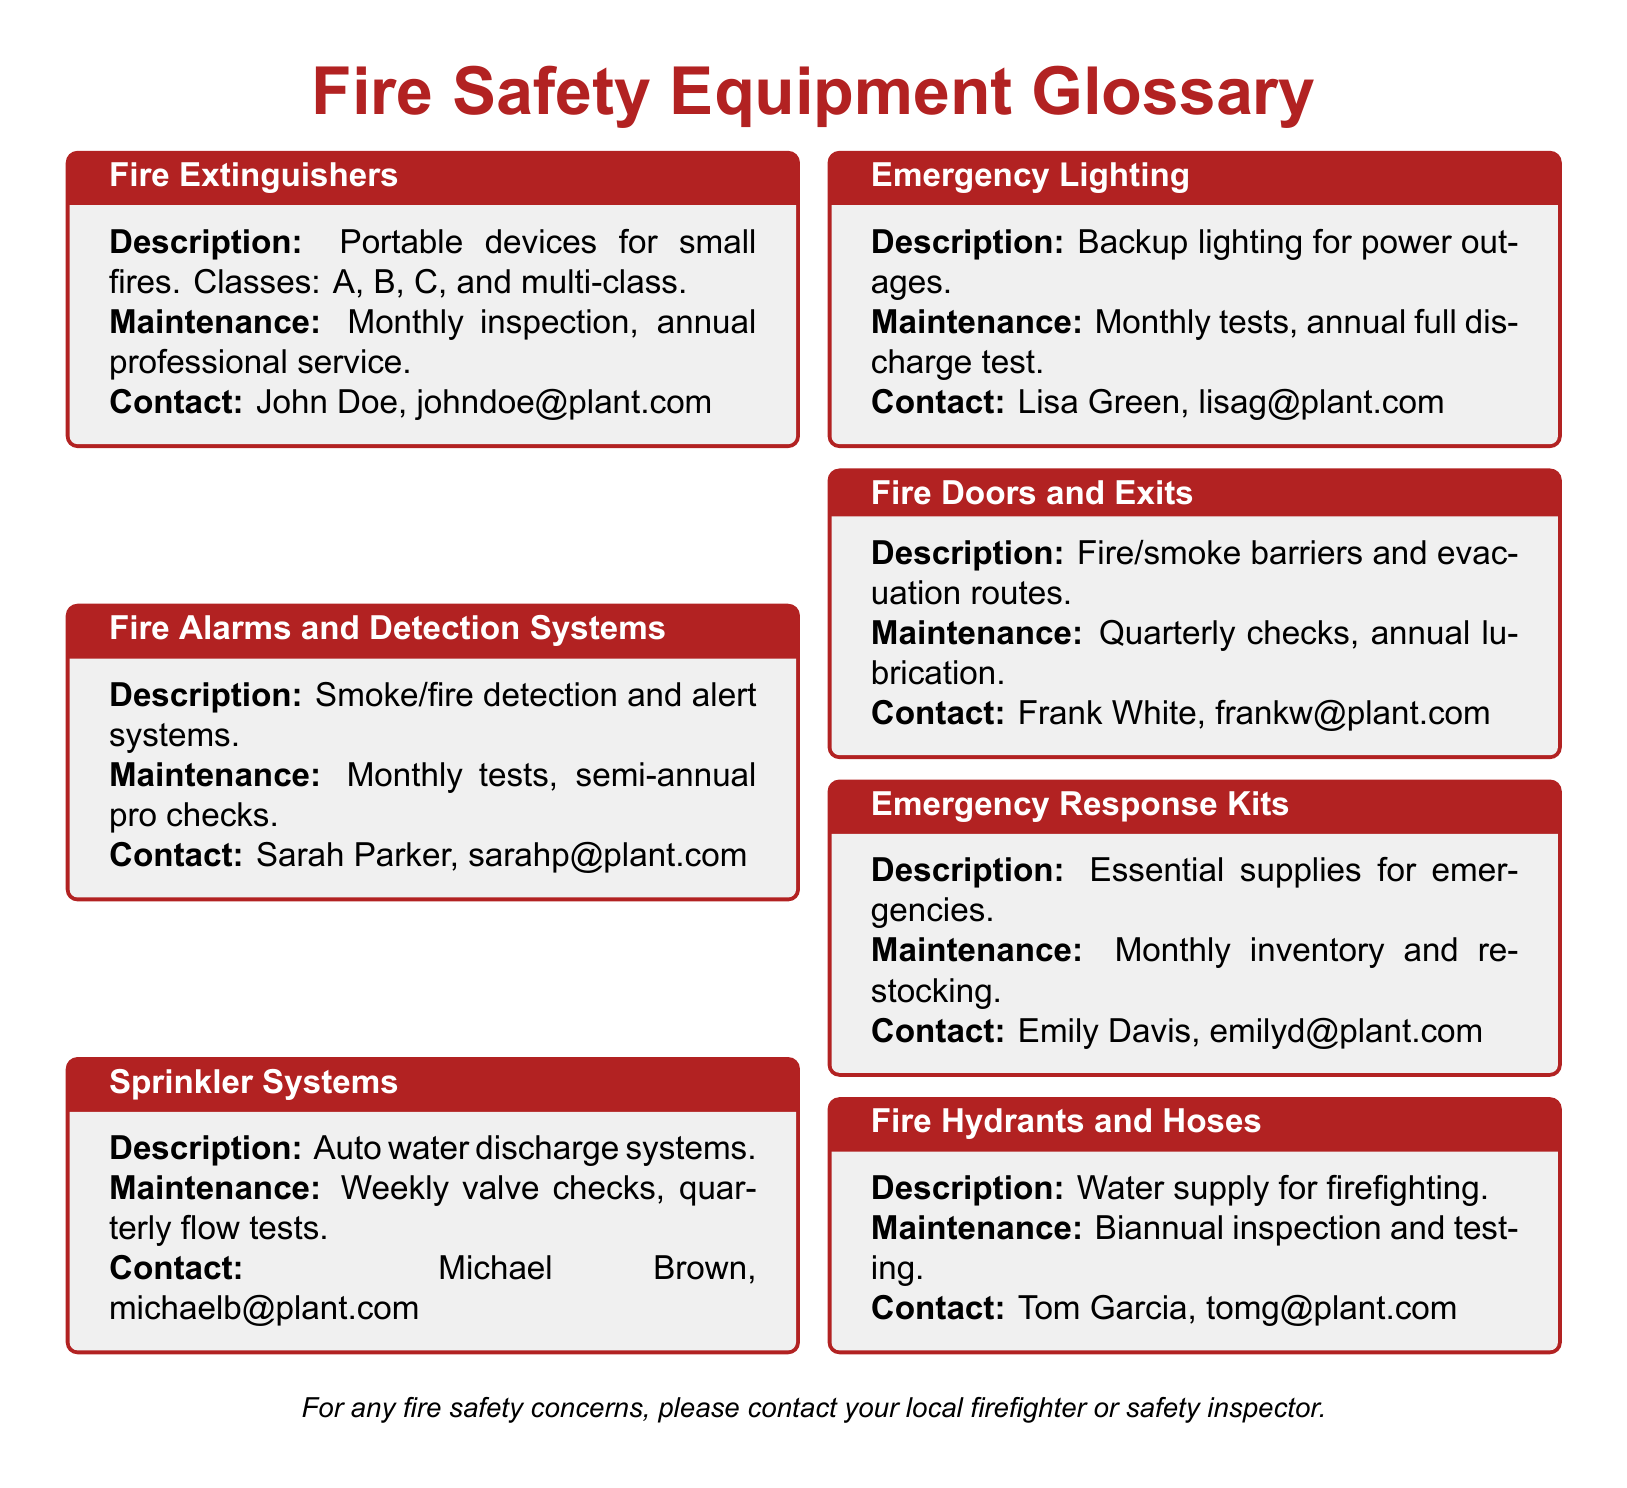what is the maintenance frequency for fire extinguishers? The document states that fire extinguishers require a monthly inspection and annual professional service.
Answer: Monthly inspection, annual professional service who should be contacted for fire alarm maintenance? The contact information provided in the document lists Sarah Parker as the person for fire alarm maintenance.
Answer: Sarah Parker, sarahp@plant.com how often should emergency lighting systems be tested? According to the document, emergency lighting systems need to be tested monthly and require an annual full discharge test.
Answer: Monthly tests, annual full discharge test what is the maintenance schedule for sprinkler systems? The document mentions that sprinkler systems require weekly valve checks and quarterly flow tests as part of their maintenance schedule.
Answer: Weekly valve checks, quarterly flow tests what type of systems are described in the fire alarms and detection systems section? The document describes smoke/fire detection and alert systems under the fire alarms and detection systems section.
Answer: Smoke/fire detection and alert systems which fire safety equipment requires a biannual inspection? The document specifies that fire hydrants and hoses need a biannual inspection and testing.
Answer: Fire hydrants and hoses who is responsible for the maintenance of emergency response kits? The document attributes the maintenance of emergency response kits to Emily Davis.
Answer: Emily Davis, emilyd@plant.com how often should fire doors and exits be checked? Fire doors and exits are required to have quarterly checks and annual lubrication according to the document.
Answer: Quarterly checks, annual lubrication what are fire extinguishers classified by? The document states that fire extinguishers are classified by classes A, B, C, and multi-class.
Answer: Classes: A, B, C, multi-class 